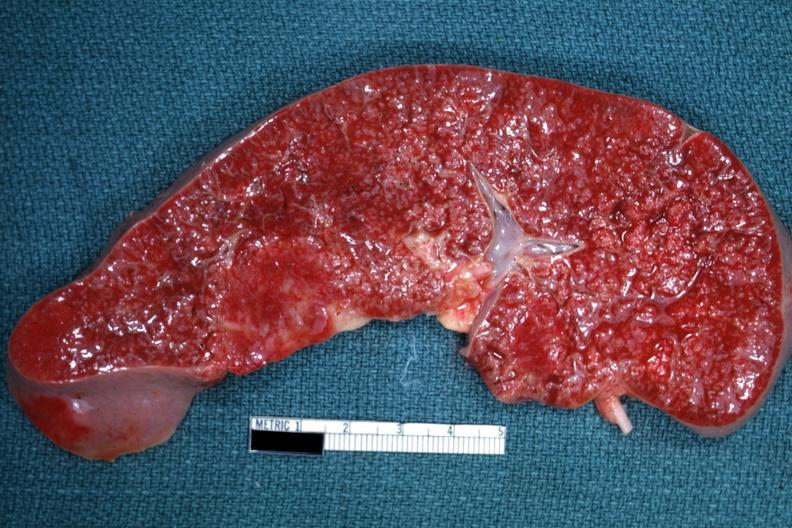what is granulomata diagnosed?
Answer the question using a single word or phrase. As reticulum cell sarcoma 